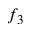<formula> <loc_0><loc_0><loc_500><loc_500>f _ { 3 }</formula> 